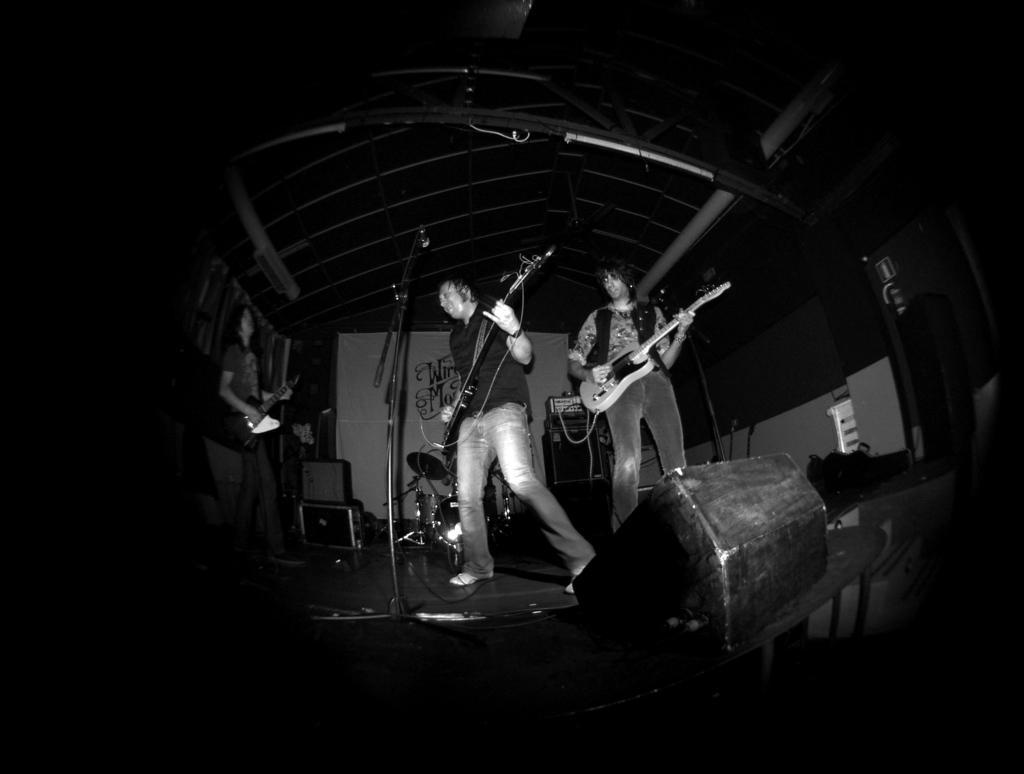How would you summarize this image in a sentence or two? In this image there are three person standing and there are playing a guitar. There is a mic and a stand. 